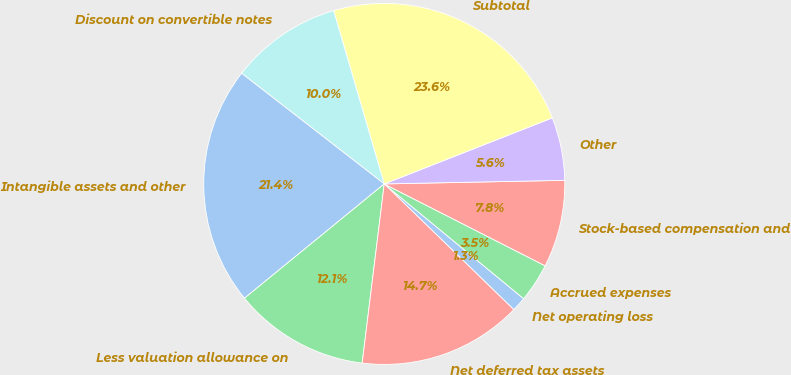<chart> <loc_0><loc_0><loc_500><loc_500><pie_chart><fcel>Net operating loss<fcel>Accrued expenses<fcel>Stock-based compensation and<fcel>Other<fcel>Subtotal<fcel>Discount on convertible notes<fcel>Intangible assets and other<fcel>Less valuation allowance on<fcel>Net deferred tax assets<nl><fcel>1.3%<fcel>3.47%<fcel>7.81%<fcel>5.64%<fcel>23.57%<fcel>9.98%<fcel>21.41%<fcel>12.14%<fcel>14.69%<nl></chart> 